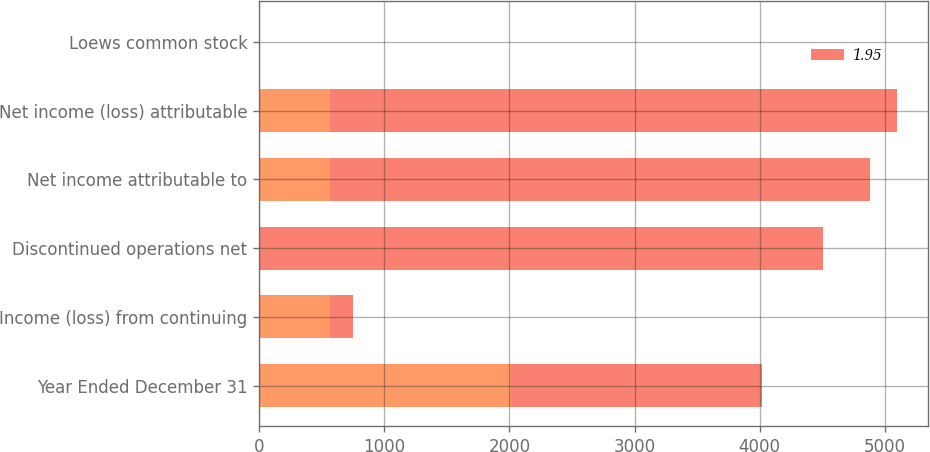<chart> <loc_0><loc_0><loc_500><loc_500><stacked_bar_chart><ecel><fcel>Year Ended December 31<fcel>Income (loss) from continuing<fcel>Discontinued operations net<fcel>Net income attributable to<fcel>Net income (loss) attributable<fcel>Loews common stock<nl><fcel>nan<fcel>2009<fcel>566<fcel>2<fcel>564<fcel>564<fcel>1.3<nl><fcel>1.95<fcel>2008<fcel>182<fcel>4501<fcel>4319<fcel>4530<fcel>9.05<nl></chart> 